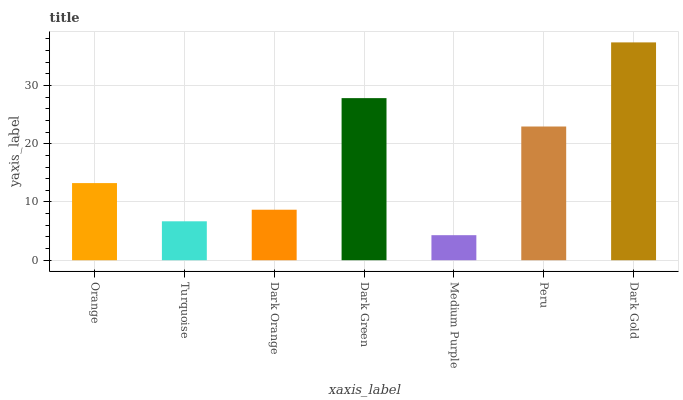Is Medium Purple the minimum?
Answer yes or no. Yes. Is Dark Gold the maximum?
Answer yes or no. Yes. Is Turquoise the minimum?
Answer yes or no. No. Is Turquoise the maximum?
Answer yes or no. No. Is Orange greater than Turquoise?
Answer yes or no. Yes. Is Turquoise less than Orange?
Answer yes or no. Yes. Is Turquoise greater than Orange?
Answer yes or no. No. Is Orange less than Turquoise?
Answer yes or no. No. Is Orange the high median?
Answer yes or no. Yes. Is Orange the low median?
Answer yes or no. Yes. Is Peru the high median?
Answer yes or no. No. Is Dark Gold the low median?
Answer yes or no. No. 